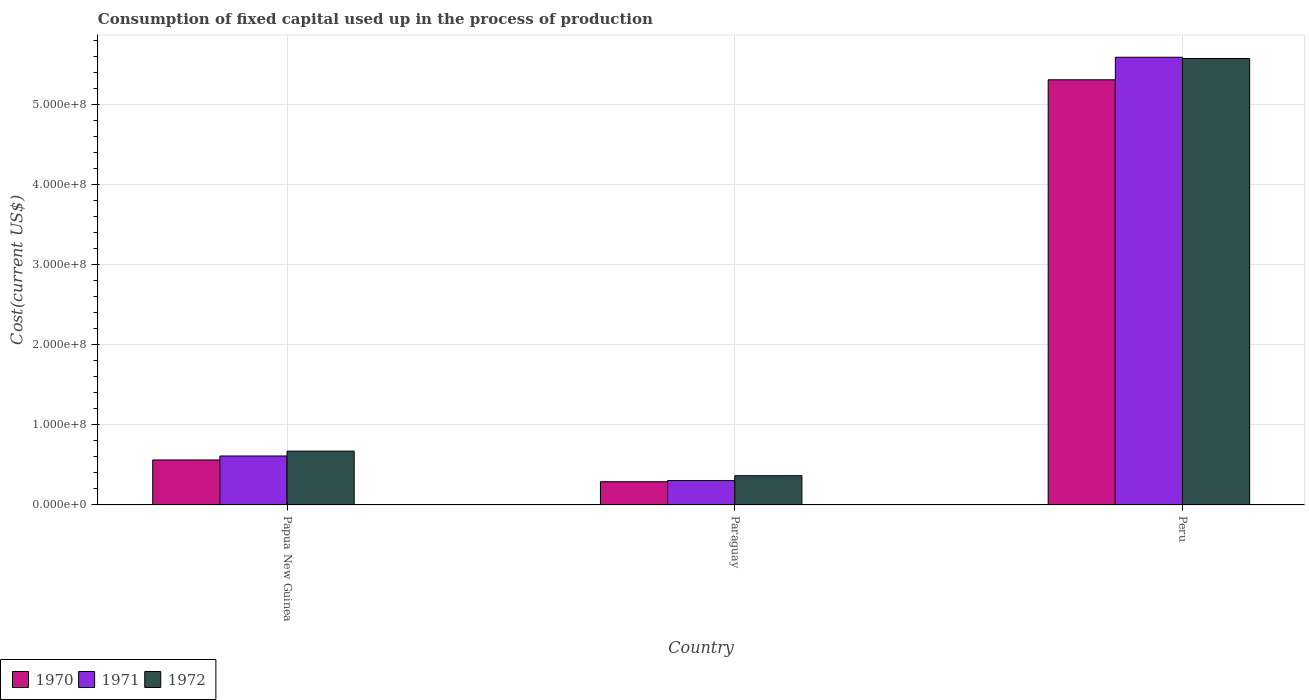How many different coloured bars are there?
Give a very brief answer. 3. Are the number of bars per tick equal to the number of legend labels?
Your answer should be very brief. Yes. Are the number of bars on each tick of the X-axis equal?
Keep it short and to the point. Yes. How many bars are there on the 3rd tick from the left?
Provide a short and direct response. 3. In how many cases, is the number of bars for a given country not equal to the number of legend labels?
Keep it short and to the point. 0. What is the amount consumed in the process of production in 1971 in Paraguay?
Make the answer very short. 3.05e+07. Across all countries, what is the maximum amount consumed in the process of production in 1970?
Your response must be concise. 5.31e+08. Across all countries, what is the minimum amount consumed in the process of production in 1971?
Make the answer very short. 3.05e+07. In which country was the amount consumed in the process of production in 1971 maximum?
Give a very brief answer. Peru. In which country was the amount consumed in the process of production in 1970 minimum?
Make the answer very short. Paraguay. What is the total amount consumed in the process of production in 1971 in the graph?
Make the answer very short. 6.51e+08. What is the difference between the amount consumed in the process of production in 1972 in Papua New Guinea and that in Paraguay?
Offer a terse response. 3.07e+07. What is the difference between the amount consumed in the process of production in 1970 in Papua New Guinea and the amount consumed in the process of production in 1971 in Paraguay?
Provide a succinct answer. 2.57e+07. What is the average amount consumed in the process of production in 1971 per country?
Offer a very short reply. 2.17e+08. What is the difference between the amount consumed in the process of production of/in 1970 and amount consumed in the process of production of/in 1971 in Paraguay?
Your response must be concise. -1.46e+06. What is the ratio of the amount consumed in the process of production in 1971 in Papua New Guinea to that in Peru?
Provide a short and direct response. 0.11. Is the amount consumed in the process of production in 1972 in Paraguay less than that in Peru?
Your answer should be compact. Yes. Is the difference between the amount consumed in the process of production in 1970 in Paraguay and Peru greater than the difference between the amount consumed in the process of production in 1971 in Paraguay and Peru?
Make the answer very short. Yes. What is the difference between the highest and the second highest amount consumed in the process of production in 1970?
Provide a short and direct response. 5.02e+08. What is the difference between the highest and the lowest amount consumed in the process of production in 1970?
Ensure brevity in your answer.  5.02e+08. What does the 2nd bar from the left in Papua New Guinea represents?
Offer a terse response. 1971. What does the 2nd bar from the right in Paraguay represents?
Offer a very short reply. 1971. How many bars are there?
Give a very brief answer. 9. Are all the bars in the graph horizontal?
Offer a terse response. No. How many countries are there in the graph?
Offer a terse response. 3. Are the values on the major ticks of Y-axis written in scientific E-notation?
Make the answer very short. Yes. Does the graph contain any zero values?
Ensure brevity in your answer.  No. Does the graph contain grids?
Make the answer very short. Yes. Where does the legend appear in the graph?
Make the answer very short. Bottom left. How are the legend labels stacked?
Offer a terse response. Horizontal. What is the title of the graph?
Your answer should be compact. Consumption of fixed capital used up in the process of production. Does "1964" appear as one of the legend labels in the graph?
Your answer should be very brief. No. What is the label or title of the X-axis?
Provide a short and direct response. Country. What is the label or title of the Y-axis?
Your response must be concise. Cost(current US$). What is the Cost(current US$) in 1970 in Papua New Guinea?
Your response must be concise. 5.62e+07. What is the Cost(current US$) of 1971 in Papua New Guinea?
Keep it short and to the point. 6.12e+07. What is the Cost(current US$) in 1972 in Papua New Guinea?
Your response must be concise. 6.73e+07. What is the Cost(current US$) in 1970 in Paraguay?
Provide a short and direct response. 2.90e+07. What is the Cost(current US$) of 1971 in Paraguay?
Provide a short and direct response. 3.05e+07. What is the Cost(current US$) in 1972 in Paraguay?
Give a very brief answer. 3.66e+07. What is the Cost(current US$) in 1970 in Peru?
Ensure brevity in your answer.  5.31e+08. What is the Cost(current US$) of 1971 in Peru?
Your answer should be compact. 5.60e+08. What is the Cost(current US$) of 1972 in Peru?
Your answer should be very brief. 5.58e+08. Across all countries, what is the maximum Cost(current US$) of 1970?
Your answer should be very brief. 5.31e+08. Across all countries, what is the maximum Cost(current US$) of 1971?
Ensure brevity in your answer.  5.60e+08. Across all countries, what is the maximum Cost(current US$) of 1972?
Make the answer very short. 5.58e+08. Across all countries, what is the minimum Cost(current US$) in 1970?
Provide a short and direct response. 2.90e+07. Across all countries, what is the minimum Cost(current US$) in 1971?
Give a very brief answer. 3.05e+07. Across all countries, what is the minimum Cost(current US$) in 1972?
Your answer should be very brief. 3.66e+07. What is the total Cost(current US$) of 1970 in the graph?
Your response must be concise. 6.17e+08. What is the total Cost(current US$) of 1971 in the graph?
Offer a terse response. 6.51e+08. What is the total Cost(current US$) of 1972 in the graph?
Offer a very short reply. 6.62e+08. What is the difference between the Cost(current US$) in 1970 in Papua New Guinea and that in Paraguay?
Your answer should be very brief. 2.72e+07. What is the difference between the Cost(current US$) in 1971 in Papua New Guinea and that in Paraguay?
Offer a very short reply. 3.07e+07. What is the difference between the Cost(current US$) in 1972 in Papua New Guinea and that in Paraguay?
Ensure brevity in your answer.  3.07e+07. What is the difference between the Cost(current US$) of 1970 in Papua New Guinea and that in Peru?
Make the answer very short. -4.75e+08. What is the difference between the Cost(current US$) of 1971 in Papua New Guinea and that in Peru?
Give a very brief answer. -4.98e+08. What is the difference between the Cost(current US$) in 1972 in Papua New Guinea and that in Peru?
Your answer should be very brief. -4.91e+08. What is the difference between the Cost(current US$) in 1970 in Paraguay and that in Peru?
Make the answer very short. -5.02e+08. What is the difference between the Cost(current US$) of 1971 in Paraguay and that in Peru?
Your answer should be compact. -5.29e+08. What is the difference between the Cost(current US$) in 1972 in Paraguay and that in Peru?
Your response must be concise. -5.22e+08. What is the difference between the Cost(current US$) of 1970 in Papua New Guinea and the Cost(current US$) of 1971 in Paraguay?
Keep it short and to the point. 2.57e+07. What is the difference between the Cost(current US$) of 1970 in Papua New Guinea and the Cost(current US$) of 1972 in Paraguay?
Offer a terse response. 1.97e+07. What is the difference between the Cost(current US$) of 1971 in Papua New Guinea and the Cost(current US$) of 1972 in Paraguay?
Offer a terse response. 2.46e+07. What is the difference between the Cost(current US$) in 1970 in Papua New Guinea and the Cost(current US$) in 1971 in Peru?
Give a very brief answer. -5.03e+08. What is the difference between the Cost(current US$) in 1970 in Papua New Guinea and the Cost(current US$) in 1972 in Peru?
Your answer should be compact. -5.02e+08. What is the difference between the Cost(current US$) of 1971 in Papua New Guinea and the Cost(current US$) of 1972 in Peru?
Offer a terse response. -4.97e+08. What is the difference between the Cost(current US$) of 1970 in Paraguay and the Cost(current US$) of 1971 in Peru?
Give a very brief answer. -5.31e+08. What is the difference between the Cost(current US$) in 1970 in Paraguay and the Cost(current US$) in 1972 in Peru?
Provide a short and direct response. -5.29e+08. What is the difference between the Cost(current US$) of 1971 in Paraguay and the Cost(current US$) of 1972 in Peru?
Keep it short and to the point. -5.28e+08. What is the average Cost(current US$) of 1970 per country?
Your answer should be compact. 2.06e+08. What is the average Cost(current US$) of 1971 per country?
Provide a short and direct response. 2.17e+08. What is the average Cost(current US$) of 1972 per country?
Your answer should be compact. 2.21e+08. What is the difference between the Cost(current US$) of 1970 and Cost(current US$) of 1971 in Papua New Guinea?
Your response must be concise. -4.97e+06. What is the difference between the Cost(current US$) of 1970 and Cost(current US$) of 1972 in Papua New Guinea?
Make the answer very short. -1.11e+07. What is the difference between the Cost(current US$) in 1971 and Cost(current US$) in 1972 in Papua New Guinea?
Your answer should be very brief. -6.09e+06. What is the difference between the Cost(current US$) in 1970 and Cost(current US$) in 1971 in Paraguay?
Make the answer very short. -1.46e+06. What is the difference between the Cost(current US$) in 1970 and Cost(current US$) in 1972 in Paraguay?
Your answer should be compact. -7.54e+06. What is the difference between the Cost(current US$) in 1971 and Cost(current US$) in 1972 in Paraguay?
Keep it short and to the point. -6.08e+06. What is the difference between the Cost(current US$) in 1970 and Cost(current US$) in 1971 in Peru?
Your response must be concise. -2.82e+07. What is the difference between the Cost(current US$) in 1970 and Cost(current US$) in 1972 in Peru?
Give a very brief answer. -2.66e+07. What is the difference between the Cost(current US$) of 1971 and Cost(current US$) of 1972 in Peru?
Offer a very short reply. 1.53e+06. What is the ratio of the Cost(current US$) of 1970 in Papua New Guinea to that in Paraguay?
Your answer should be very brief. 1.94. What is the ratio of the Cost(current US$) of 1971 in Papua New Guinea to that in Paraguay?
Provide a succinct answer. 2.01. What is the ratio of the Cost(current US$) in 1972 in Papua New Guinea to that in Paraguay?
Keep it short and to the point. 1.84. What is the ratio of the Cost(current US$) in 1970 in Papua New Guinea to that in Peru?
Provide a short and direct response. 0.11. What is the ratio of the Cost(current US$) in 1971 in Papua New Guinea to that in Peru?
Give a very brief answer. 0.11. What is the ratio of the Cost(current US$) in 1972 in Papua New Guinea to that in Peru?
Ensure brevity in your answer.  0.12. What is the ratio of the Cost(current US$) in 1970 in Paraguay to that in Peru?
Give a very brief answer. 0.05. What is the ratio of the Cost(current US$) of 1971 in Paraguay to that in Peru?
Provide a short and direct response. 0.05. What is the ratio of the Cost(current US$) in 1972 in Paraguay to that in Peru?
Provide a short and direct response. 0.07. What is the difference between the highest and the second highest Cost(current US$) in 1970?
Provide a short and direct response. 4.75e+08. What is the difference between the highest and the second highest Cost(current US$) in 1971?
Give a very brief answer. 4.98e+08. What is the difference between the highest and the second highest Cost(current US$) in 1972?
Provide a short and direct response. 4.91e+08. What is the difference between the highest and the lowest Cost(current US$) in 1970?
Make the answer very short. 5.02e+08. What is the difference between the highest and the lowest Cost(current US$) in 1971?
Your answer should be compact. 5.29e+08. What is the difference between the highest and the lowest Cost(current US$) in 1972?
Provide a succinct answer. 5.22e+08. 